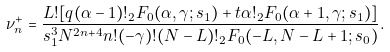Convert formula to latex. <formula><loc_0><loc_0><loc_500><loc_500>\nu ^ { + } _ { n } = \frac { L ! [ q ( \alpha - 1 ) ! { _ { 2 } } F _ { 0 } ( \alpha , \gamma ; s _ { 1 } ) + t { \alpha } ! { _ { 2 } } F _ { 0 } ( \alpha + 1 , \gamma ; s _ { 1 } ) ] } { s _ { 1 } ^ { 3 } N ^ { 2 n + 4 } n ! ( - \gamma ) ! ( N - L ) ! { _ { 2 } } F _ { 0 } ( - L , N - L + 1 ; s _ { 0 } ) } .</formula> 